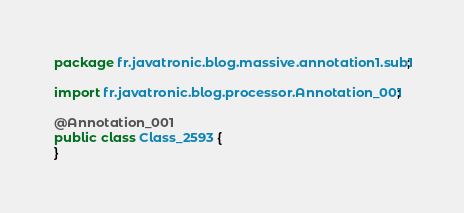Convert code to text. <code><loc_0><loc_0><loc_500><loc_500><_Java_>package fr.javatronic.blog.massive.annotation1.sub1;

import fr.javatronic.blog.processor.Annotation_001;

@Annotation_001
public class Class_2593 {
}
</code> 